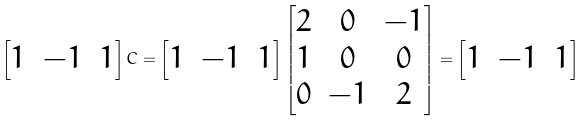Convert formula to latex. <formula><loc_0><loc_0><loc_500><loc_500>\left [ \begin{matrix} 1 & - 1 & 1 \end{matrix} \right ] C = \left [ \begin{matrix} 1 & - 1 & 1 \end{matrix} \right ] \left [ \begin{matrix} 2 & 0 & - 1 \\ 1 & 0 & 0 \\ 0 & - 1 & 2 \end{matrix} \right ] = \left [ \begin{matrix} 1 & - 1 & 1 \end{matrix} \right ]</formula> 